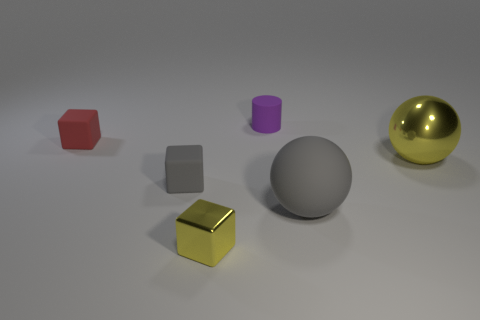There is a metal thing to the right of the yellow shiny thing that is on the left side of the tiny cylinder; what is its color?
Ensure brevity in your answer.  Yellow. How many purple objects are either small metallic cubes or blocks?
Keep it short and to the point. 0. The matte object that is on the right side of the tiny gray matte thing and in front of the small red matte thing is what color?
Make the answer very short. Gray. What number of small things are either red metal things or gray balls?
Keep it short and to the point. 0. What is the size of the other object that is the same shape as the big yellow metallic object?
Offer a very short reply. Large. There is a big yellow thing; what shape is it?
Offer a terse response. Sphere. Is the big gray ball made of the same material as the yellow object that is right of the small yellow object?
Provide a short and direct response. No. What number of metallic objects are either tiny cylinders or balls?
Keep it short and to the point. 1. There is a matte block that is to the right of the tiny red block; what size is it?
Your response must be concise. Small. What is the size of the ball that is the same material as the gray block?
Make the answer very short. Large. 